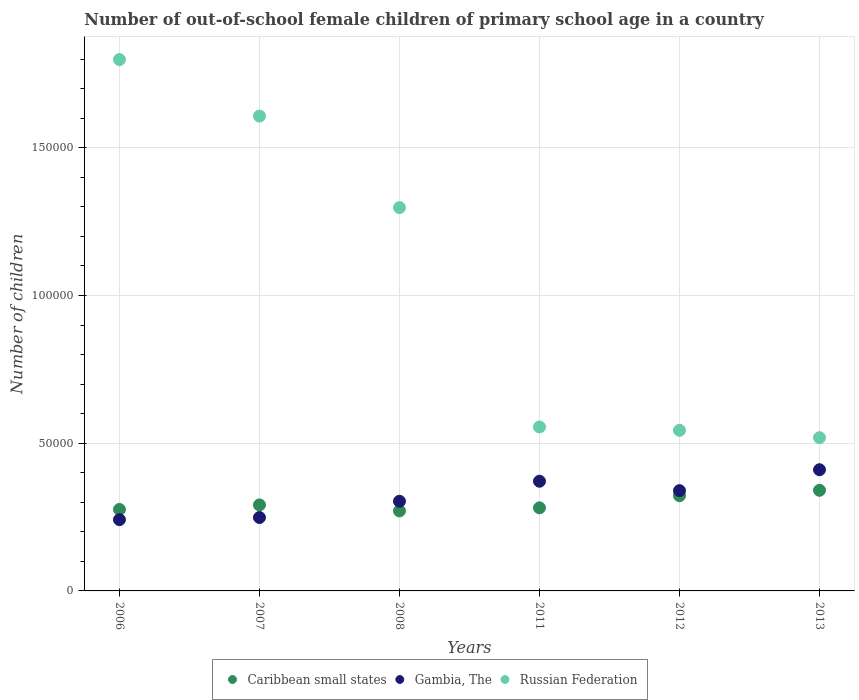How many different coloured dotlines are there?
Your answer should be compact. 3. Is the number of dotlines equal to the number of legend labels?
Offer a very short reply. Yes. What is the number of out-of-school female children in Gambia, The in 2006?
Your answer should be very brief. 2.41e+04. Across all years, what is the maximum number of out-of-school female children in Gambia, The?
Your answer should be compact. 4.10e+04. Across all years, what is the minimum number of out-of-school female children in Caribbean small states?
Keep it short and to the point. 2.71e+04. What is the total number of out-of-school female children in Gambia, The in the graph?
Offer a very short reply. 1.91e+05. What is the difference between the number of out-of-school female children in Russian Federation in 2008 and that in 2012?
Provide a short and direct response. 7.54e+04. What is the difference between the number of out-of-school female children in Gambia, The in 2006 and the number of out-of-school female children in Russian Federation in 2012?
Your answer should be compact. -3.02e+04. What is the average number of out-of-school female children in Gambia, The per year?
Give a very brief answer. 3.19e+04. In the year 2011, what is the difference between the number of out-of-school female children in Gambia, The and number of out-of-school female children in Russian Federation?
Keep it short and to the point. -1.84e+04. In how many years, is the number of out-of-school female children in Gambia, The greater than 120000?
Give a very brief answer. 0. What is the ratio of the number of out-of-school female children in Caribbean small states in 2006 to that in 2012?
Keep it short and to the point. 0.86. Is the number of out-of-school female children in Gambia, The in 2011 less than that in 2013?
Offer a very short reply. Yes. Is the difference between the number of out-of-school female children in Gambia, The in 2006 and 2011 greater than the difference between the number of out-of-school female children in Russian Federation in 2006 and 2011?
Your answer should be very brief. No. What is the difference between the highest and the second highest number of out-of-school female children in Russian Federation?
Provide a short and direct response. 1.91e+04. What is the difference between the highest and the lowest number of out-of-school female children in Russian Federation?
Offer a terse response. 1.28e+05. Is the sum of the number of out-of-school female children in Gambia, The in 2007 and 2008 greater than the maximum number of out-of-school female children in Caribbean small states across all years?
Provide a short and direct response. Yes. Is it the case that in every year, the sum of the number of out-of-school female children in Gambia, The and number of out-of-school female children in Russian Federation  is greater than the number of out-of-school female children in Caribbean small states?
Your answer should be compact. Yes. Does the number of out-of-school female children in Caribbean small states monotonically increase over the years?
Give a very brief answer. No. Is the number of out-of-school female children in Gambia, The strictly greater than the number of out-of-school female children in Caribbean small states over the years?
Give a very brief answer. No. Is the number of out-of-school female children in Caribbean small states strictly less than the number of out-of-school female children in Gambia, The over the years?
Your response must be concise. No. How many dotlines are there?
Offer a terse response. 3. What is the difference between two consecutive major ticks on the Y-axis?
Ensure brevity in your answer.  5.00e+04. Does the graph contain grids?
Offer a terse response. Yes. What is the title of the graph?
Provide a succinct answer. Number of out-of-school female children of primary school age in a country. What is the label or title of the Y-axis?
Your response must be concise. Number of children. What is the Number of children of Caribbean small states in 2006?
Your answer should be compact. 2.76e+04. What is the Number of children in Gambia, The in 2006?
Your answer should be compact. 2.41e+04. What is the Number of children in Russian Federation in 2006?
Provide a short and direct response. 1.80e+05. What is the Number of children in Caribbean small states in 2007?
Provide a short and direct response. 2.91e+04. What is the Number of children of Gambia, The in 2007?
Provide a short and direct response. 2.48e+04. What is the Number of children of Russian Federation in 2007?
Your answer should be compact. 1.61e+05. What is the Number of children in Caribbean small states in 2008?
Your response must be concise. 2.71e+04. What is the Number of children of Gambia, The in 2008?
Provide a succinct answer. 3.03e+04. What is the Number of children in Russian Federation in 2008?
Your response must be concise. 1.30e+05. What is the Number of children of Caribbean small states in 2011?
Your answer should be compact. 2.81e+04. What is the Number of children of Gambia, The in 2011?
Your response must be concise. 3.71e+04. What is the Number of children of Russian Federation in 2011?
Offer a terse response. 5.55e+04. What is the Number of children in Caribbean small states in 2012?
Provide a short and direct response. 3.22e+04. What is the Number of children of Gambia, The in 2012?
Make the answer very short. 3.39e+04. What is the Number of children in Russian Federation in 2012?
Offer a very short reply. 5.44e+04. What is the Number of children of Caribbean small states in 2013?
Your answer should be compact. 3.41e+04. What is the Number of children in Gambia, The in 2013?
Give a very brief answer. 4.10e+04. What is the Number of children of Russian Federation in 2013?
Provide a succinct answer. 5.19e+04. Across all years, what is the maximum Number of children of Caribbean small states?
Make the answer very short. 3.41e+04. Across all years, what is the maximum Number of children of Gambia, The?
Your response must be concise. 4.10e+04. Across all years, what is the maximum Number of children in Russian Federation?
Provide a succinct answer. 1.80e+05. Across all years, what is the minimum Number of children of Caribbean small states?
Your response must be concise. 2.71e+04. Across all years, what is the minimum Number of children of Gambia, The?
Keep it short and to the point. 2.41e+04. Across all years, what is the minimum Number of children in Russian Federation?
Your answer should be compact. 5.19e+04. What is the total Number of children of Caribbean small states in the graph?
Your answer should be very brief. 1.78e+05. What is the total Number of children of Gambia, The in the graph?
Make the answer very short. 1.91e+05. What is the total Number of children of Russian Federation in the graph?
Offer a terse response. 6.32e+05. What is the difference between the Number of children of Caribbean small states in 2006 and that in 2007?
Your response must be concise. -1533. What is the difference between the Number of children in Gambia, The in 2006 and that in 2007?
Give a very brief answer. -727. What is the difference between the Number of children of Russian Federation in 2006 and that in 2007?
Keep it short and to the point. 1.91e+04. What is the difference between the Number of children in Caribbean small states in 2006 and that in 2008?
Make the answer very short. 492. What is the difference between the Number of children in Gambia, The in 2006 and that in 2008?
Ensure brevity in your answer.  -6231. What is the difference between the Number of children in Russian Federation in 2006 and that in 2008?
Give a very brief answer. 5.01e+04. What is the difference between the Number of children of Caribbean small states in 2006 and that in 2011?
Make the answer very short. -551. What is the difference between the Number of children of Gambia, The in 2006 and that in 2011?
Ensure brevity in your answer.  -1.30e+04. What is the difference between the Number of children in Russian Federation in 2006 and that in 2011?
Offer a terse response. 1.24e+05. What is the difference between the Number of children of Caribbean small states in 2006 and that in 2012?
Give a very brief answer. -4653. What is the difference between the Number of children in Gambia, The in 2006 and that in 2012?
Keep it short and to the point. -9820. What is the difference between the Number of children of Russian Federation in 2006 and that in 2012?
Keep it short and to the point. 1.25e+05. What is the difference between the Number of children of Caribbean small states in 2006 and that in 2013?
Make the answer very short. -6486. What is the difference between the Number of children in Gambia, The in 2006 and that in 2013?
Provide a succinct answer. -1.69e+04. What is the difference between the Number of children of Russian Federation in 2006 and that in 2013?
Make the answer very short. 1.28e+05. What is the difference between the Number of children of Caribbean small states in 2007 and that in 2008?
Provide a succinct answer. 2025. What is the difference between the Number of children of Gambia, The in 2007 and that in 2008?
Give a very brief answer. -5504. What is the difference between the Number of children of Russian Federation in 2007 and that in 2008?
Your answer should be very brief. 3.10e+04. What is the difference between the Number of children of Caribbean small states in 2007 and that in 2011?
Provide a short and direct response. 982. What is the difference between the Number of children of Gambia, The in 2007 and that in 2011?
Provide a short and direct response. -1.23e+04. What is the difference between the Number of children in Russian Federation in 2007 and that in 2011?
Provide a short and direct response. 1.05e+05. What is the difference between the Number of children in Caribbean small states in 2007 and that in 2012?
Provide a succinct answer. -3120. What is the difference between the Number of children of Gambia, The in 2007 and that in 2012?
Offer a very short reply. -9093. What is the difference between the Number of children in Russian Federation in 2007 and that in 2012?
Keep it short and to the point. 1.06e+05. What is the difference between the Number of children in Caribbean small states in 2007 and that in 2013?
Provide a succinct answer. -4953. What is the difference between the Number of children of Gambia, The in 2007 and that in 2013?
Offer a very short reply. -1.62e+04. What is the difference between the Number of children of Russian Federation in 2007 and that in 2013?
Provide a succinct answer. 1.09e+05. What is the difference between the Number of children of Caribbean small states in 2008 and that in 2011?
Offer a terse response. -1043. What is the difference between the Number of children of Gambia, The in 2008 and that in 2011?
Keep it short and to the point. -6775. What is the difference between the Number of children of Russian Federation in 2008 and that in 2011?
Offer a terse response. 7.42e+04. What is the difference between the Number of children in Caribbean small states in 2008 and that in 2012?
Offer a terse response. -5145. What is the difference between the Number of children of Gambia, The in 2008 and that in 2012?
Your answer should be compact. -3589. What is the difference between the Number of children of Russian Federation in 2008 and that in 2012?
Keep it short and to the point. 7.54e+04. What is the difference between the Number of children in Caribbean small states in 2008 and that in 2013?
Give a very brief answer. -6978. What is the difference between the Number of children of Gambia, The in 2008 and that in 2013?
Make the answer very short. -1.07e+04. What is the difference between the Number of children in Russian Federation in 2008 and that in 2013?
Your response must be concise. 7.79e+04. What is the difference between the Number of children of Caribbean small states in 2011 and that in 2012?
Give a very brief answer. -4102. What is the difference between the Number of children in Gambia, The in 2011 and that in 2012?
Keep it short and to the point. 3186. What is the difference between the Number of children in Russian Federation in 2011 and that in 2012?
Offer a terse response. 1138. What is the difference between the Number of children in Caribbean small states in 2011 and that in 2013?
Provide a succinct answer. -5935. What is the difference between the Number of children in Gambia, The in 2011 and that in 2013?
Your answer should be compact. -3895. What is the difference between the Number of children of Russian Federation in 2011 and that in 2013?
Provide a short and direct response. 3629. What is the difference between the Number of children of Caribbean small states in 2012 and that in 2013?
Your answer should be very brief. -1833. What is the difference between the Number of children of Gambia, The in 2012 and that in 2013?
Ensure brevity in your answer.  -7081. What is the difference between the Number of children in Russian Federation in 2012 and that in 2013?
Offer a terse response. 2491. What is the difference between the Number of children of Caribbean small states in 2006 and the Number of children of Gambia, The in 2007?
Provide a short and direct response. 2729. What is the difference between the Number of children of Caribbean small states in 2006 and the Number of children of Russian Federation in 2007?
Give a very brief answer. -1.33e+05. What is the difference between the Number of children of Gambia, The in 2006 and the Number of children of Russian Federation in 2007?
Give a very brief answer. -1.37e+05. What is the difference between the Number of children of Caribbean small states in 2006 and the Number of children of Gambia, The in 2008?
Give a very brief answer. -2775. What is the difference between the Number of children in Caribbean small states in 2006 and the Number of children in Russian Federation in 2008?
Your answer should be compact. -1.02e+05. What is the difference between the Number of children of Gambia, The in 2006 and the Number of children of Russian Federation in 2008?
Keep it short and to the point. -1.06e+05. What is the difference between the Number of children in Caribbean small states in 2006 and the Number of children in Gambia, The in 2011?
Your answer should be compact. -9550. What is the difference between the Number of children of Caribbean small states in 2006 and the Number of children of Russian Federation in 2011?
Your response must be concise. -2.79e+04. What is the difference between the Number of children in Gambia, The in 2006 and the Number of children in Russian Federation in 2011?
Offer a terse response. -3.14e+04. What is the difference between the Number of children of Caribbean small states in 2006 and the Number of children of Gambia, The in 2012?
Ensure brevity in your answer.  -6364. What is the difference between the Number of children in Caribbean small states in 2006 and the Number of children in Russian Federation in 2012?
Your answer should be very brief. -2.68e+04. What is the difference between the Number of children in Gambia, The in 2006 and the Number of children in Russian Federation in 2012?
Ensure brevity in your answer.  -3.02e+04. What is the difference between the Number of children of Caribbean small states in 2006 and the Number of children of Gambia, The in 2013?
Make the answer very short. -1.34e+04. What is the difference between the Number of children in Caribbean small states in 2006 and the Number of children in Russian Federation in 2013?
Offer a terse response. -2.43e+04. What is the difference between the Number of children in Gambia, The in 2006 and the Number of children in Russian Federation in 2013?
Offer a terse response. -2.78e+04. What is the difference between the Number of children of Caribbean small states in 2007 and the Number of children of Gambia, The in 2008?
Keep it short and to the point. -1242. What is the difference between the Number of children of Caribbean small states in 2007 and the Number of children of Russian Federation in 2008?
Ensure brevity in your answer.  -1.01e+05. What is the difference between the Number of children of Gambia, The in 2007 and the Number of children of Russian Federation in 2008?
Ensure brevity in your answer.  -1.05e+05. What is the difference between the Number of children in Caribbean small states in 2007 and the Number of children in Gambia, The in 2011?
Provide a succinct answer. -8017. What is the difference between the Number of children of Caribbean small states in 2007 and the Number of children of Russian Federation in 2011?
Make the answer very short. -2.64e+04. What is the difference between the Number of children in Gambia, The in 2007 and the Number of children in Russian Federation in 2011?
Provide a short and direct response. -3.07e+04. What is the difference between the Number of children in Caribbean small states in 2007 and the Number of children in Gambia, The in 2012?
Your answer should be very brief. -4831. What is the difference between the Number of children in Caribbean small states in 2007 and the Number of children in Russian Federation in 2012?
Provide a short and direct response. -2.53e+04. What is the difference between the Number of children of Gambia, The in 2007 and the Number of children of Russian Federation in 2012?
Ensure brevity in your answer.  -2.95e+04. What is the difference between the Number of children of Caribbean small states in 2007 and the Number of children of Gambia, The in 2013?
Give a very brief answer. -1.19e+04. What is the difference between the Number of children in Caribbean small states in 2007 and the Number of children in Russian Federation in 2013?
Provide a succinct answer. -2.28e+04. What is the difference between the Number of children in Gambia, The in 2007 and the Number of children in Russian Federation in 2013?
Provide a succinct answer. -2.70e+04. What is the difference between the Number of children in Caribbean small states in 2008 and the Number of children in Gambia, The in 2011?
Provide a succinct answer. -1.00e+04. What is the difference between the Number of children in Caribbean small states in 2008 and the Number of children in Russian Federation in 2011?
Offer a very short reply. -2.84e+04. What is the difference between the Number of children in Gambia, The in 2008 and the Number of children in Russian Federation in 2011?
Give a very brief answer. -2.52e+04. What is the difference between the Number of children in Caribbean small states in 2008 and the Number of children in Gambia, The in 2012?
Your response must be concise. -6856. What is the difference between the Number of children in Caribbean small states in 2008 and the Number of children in Russian Federation in 2012?
Ensure brevity in your answer.  -2.73e+04. What is the difference between the Number of children in Gambia, The in 2008 and the Number of children in Russian Federation in 2012?
Provide a short and direct response. -2.40e+04. What is the difference between the Number of children in Caribbean small states in 2008 and the Number of children in Gambia, The in 2013?
Make the answer very short. -1.39e+04. What is the difference between the Number of children of Caribbean small states in 2008 and the Number of children of Russian Federation in 2013?
Your response must be concise. -2.48e+04. What is the difference between the Number of children of Gambia, The in 2008 and the Number of children of Russian Federation in 2013?
Make the answer very short. -2.15e+04. What is the difference between the Number of children in Caribbean small states in 2011 and the Number of children in Gambia, The in 2012?
Your answer should be very brief. -5813. What is the difference between the Number of children in Caribbean small states in 2011 and the Number of children in Russian Federation in 2012?
Your answer should be compact. -2.62e+04. What is the difference between the Number of children of Gambia, The in 2011 and the Number of children of Russian Federation in 2012?
Provide a succinct answer. -1.72e+04. What is the difference between the Number of children of Caribbean small states in 2011 and the Number of children of Gambia, The in 2013?
Keep it short and to the point. -1.29e+04. What is the difference between the Number of children in Caribbean small states in 2011 and the Number of children in Russian Federation in 2013?
Provide a succinct answer. -2.37e+04. What is the difference between the Number of children in Gambia, The in 2011 and the Number of children in Russian Federation in 2013?
Provide a succinct answer. -1.47e+04. What is the difference between the Number of children of Caribbean small states in 2012 and the Number of children of Gambia, The in 2013?
Your response must be concise. -8792. What is the difference between the Number of children of Caribbean small states in 2012 and the Number of children of Russian Federation in 2013?
Your answer should be very brief. -1.96e+04. What is the difference between the Number of children in Gambia, The in 2012 and the Number of children in Russian Federation in 2013?
Ensure brevity in your answer.  -1.79e+04. What is the average Number of children in Caribbean small states per year?
Offer a very short reply. 2.97e+04. What is the average Number of children of Gambia, The per year?
Ensure brevity in your answer.  3.19e+04. What is the average Number of children in Russian Federation per year?
Provide a short and direct response. 1.05e+05. In the year 2006, what is the difference between the Number of children of Caribbean small states and Number of children of Gambia, The?
Offer a terse response. 3456. In the year 2006, what is the difference between the Number of children of Caribbean small states and Number of children of Russian Federation?
Make the answer very short. -1.52e+05. In the year 2006, what is the difference between the Number of children of Gambia, The and Number of children of Russian Federation?
Your answer should be very brief. -1.56e+05. In the year 2007, what is the difference between the Number of children in Caribbean small states and Number of children in Gambia, The?
Your response must be concise. 4262. In the year 2007, what is the difference between the Number of children in Caribbean small states and Number of children in Russian Federation?
Give a very brief answer. -1.32e+05. In the year 2007, what is the difference between the Number of children in Gambia, The and Number of children in Russian Federation?
Your answer should be compact. -1.36e+05. In the year 2008, what is the difference between the Number of children of Caribbean small states and Number of children of Gambia, The?
Provide a short and direct response. -3267. In the year 2008, what is the difference between the Number of children in Caribbean small states and Number of children in Russian Federation?
Your answer should be very brief. -1.03e+05. In the year 2008, what is the difference between the Number of children in Gambia, The and Number of children in Russian Federation?
Keep it short and to the point. -9.94e+04. In the year 2011, what is the difference between the Number of children of Caribbean small states and Number of children of Gambia, The?
Ensure brevity in your answer.  -8999. In the year 2011, what is the difference between the Number of children of Caribbean small states and Number of children of Russian Federation?
Your answer should be very brief. -2.74e+04. In the year 2011, what is the difference between the Number of children of Gambia, The and Number of children of Russian Federation?
Offer a terse response. -1.84e+04. In the year 2012, what is the difference between the Number of children of Caribbean small states and Number of children of Gambia, The?
Provide a succinct answer. -1711. In the year 2012, what is the difference between the Number of children of Caribbean small states and Number of children of Russian Federation?
Your response must be concise. -2.21e+04. In the year 2012, what is the difference between the Number of children of Gambia, The and Number of children of Russian Federation?
Your answer should be compact. -2.04e+04. In the year 2013, what is the difference between the Number of children of Caribbean small states and Number of children of Gambia, The?
Your answer should be very brief. -6959. In the year 2013, what is the difference between the Number of children of Caribbean small states and Number of children of Russian Federation?
Ensure brevity in your answer.  -1.78e+04. In the year 2013, what is the difference between the Number of children in Gambia, The and Number of children in Russian Federation?
Your answer should be compact. -1.09e+04. What is the ratio of the Number of children in Caribbean small states in 2006 to that in 2007?
Provide a short and direct response. 0.95. What is the ratio of the Number of children of Gambia, The in 2006 to that in 2007?
Provide a succinct answer. 0.97. What is the ratio of the Number of children of Russian Federation in 2006 to that in 2007?
Your response must be concise. 1.12. What is the ratio of the Number of children of Caribbean small states in 2006 to that in 2008?
Your response must be concise. 1.02. What is the ratio of the Number of children of Gambia, The in 2006 to that in 2008?
Your answer should be compact. 0.79. What is the ratio of the Number of children in Russian Federation in 2006 to that in 2008?
Your response must be concise. 1.39. What is the ratio of the Number of children of Caribbean small states in 2006 to that in 2011?
Offer a terse response. 0.98. What is the ratio of the Number of children of Gambia, The in 2006 to that in 2011?
Offer a terse response. 0.65. What is the ratio of the Number of children in Russian Federation in 2006 to that in 2011?
Make the answer very short. 3.24. What is the ratio of the Number of children of Caribbean small states in 2006 to that in 2012?
Your response must be concise. 0.86. What is the ratio of the Number of children in Gambia, The in 2006 to that in 2012?
Offer a terse response. 0.71. What is the ratio of the Number of children in Russian Federation in 2006 to that in 2012?
Provide a short and direct response. 3.31. What is the ratio of the Number of children in Caribbean small states in 2006 to that in 2013?
Provide a succinct answer. 0.81. What is the ratio of the Number of children of Gambia, The in 2006 to that in 2013?
Provide a succinct answer. 0.59. What is the ratio of the Number of children of Russian Federation in 2006 to that in 2013?
Ensure brevity in your answer.  3.47. What is the ratio of the Number of children in Caribbean small states in 2007 to that in 2008?
Give a very brief answer. 1.07. What is the ratio of the Number of children of Gambia, The in 2007 to that in 2008?
Keep it short and to the point. 0.82. What is the ratio of the Number of children in Russian Federation in 2007 to that in 2008?
Your answer should be compact. 1.24. What is the ratio of the Number of children of Caribbean small states in 2007 to that in 2011?
Offer a very short reply. 1.03. What is the ratio of the Number of children in Gambia, The in 2007 to that in 2011?
Your response must be concise. 0.67. What is the ratio of the Number of children of Russian Federation in 2007 to that in 2011?
Ensure brevity in your answer.  2.9. What is the ratio of the Number of children in Caribbean small states in 2007 to that in 2012?
Ensure brevity in your answer.  0.9. What is the ratio of the Number of children of Gambia, The in 2007 to that in 2012?
Your response must be concise. 0.73. What is the ratio of the Number of children of Russian Federation in 2007 to that in 2012?
Ensure brevity in your answer.  2.96. What is the ratio of the Number of children in Caribbean small states in 2007 to that in 2013?
Provide a succinct answer. 0.85. What is the ratio of the Number of children in Gambia, The in 2007 to that in 2013?
Your response must be concise. 0.61. What is the ratio of the Number of children in Russian Federation in 2007 to that in 2013?
Provide a short and direct response. 3.1. What is the ratio of the Number of children of Caribbean small states in 2008 to that in 2011?
Make the answer very short. 0.96. What is the ratio of the Number of children in Gambia, The in 2008 to that in 2011?
Your response must be concise. 0.82. What is the ratio of the Number of children of Russian Federation in 2008 to that in 2011?
Give a very brief answer. 2.34. What is the ratio of the Number of children in Caribbean small states in 2008 to that in 2012?
Ensure brevity in your answer.  0.84. What is the ratio of the Number of children of Gambia, The in 2008 to that in 2012?
Your answer should be very brief. 0.89. What is the ratio of the Number of children of Russian Federation in 2008 to that in 2012?
Keep it short and to the point. 2.39. What is the ratio of the Number of children of Caribbean small states in 2008 to that in 2013?
Make the answer very short. 0.8. What is the ratio of the Number of children of Gambia, The in 2008 to that in 2013?
Ensure brevity in your answer.  0.74. What is the ratio of the Number of children of Russian Federation in 2008 to that in 2013?
Your answer should be compact. 2.5. What is the ratio of the Number of children in Caribbean small states in 2011 to that in 2012?
Your response must be concise. 0.87. What is the ratio of the Number of children of Gambia, The in 2011 to that in 2012?
Offer a very short reply. 1.09. What is the ratio of the Number of children in Russian Federation in 2011 to that in 2012?
Provide a succinct answer. 1.02. What is the ratio of the Number of children of Caribbean small states in 2011 to that in 2013?
Offer a terse response. 0.83. What is the ratio of the Number of children in Gambia, The in 2011 to that in 2013?
Provide a short and direct response. 0.91. What is the ratio of the Number of children of Russian Federation in 2011 to that in 2013?
Keep it short and to the point. 1.07. What is the ratio of the Number of children in Caribbean small states in 2012 to that in 2013?
Keep it short and to the point. 0.95. What is the ratio of the Number of children in Gambia, The in 2012 to that in 2013?
Make the answer very short. 0.83. What is the ratio of the Number of children in Russian Federation in 2012 to that in 2013?
Ensure brevity in your answer.  1.05. What is the difference between the highest and the second highest Number of children in Caribbean small states?
Provide a succinct answer. 1833. What is the difference between the highest and the second highest Number of children of Gambia, The?
Your response must be concise. 3895. What is the difference between the highest and the second highest Number of children of Russian Federation?
Keep it short and to the point. 1.91e+04. What is the difference between the highest and the lowest Number of children in Caribbean small states?
Your answer should be compact. 6978. What is the difference between the highest and the lowest Number of children of Gambia, The?
Your answer should be very brief. 1.69e+04. What is the difference between the highest and the lowest Number of children of Russian Federation?
Your answer should be compact. 1.28e+05. 